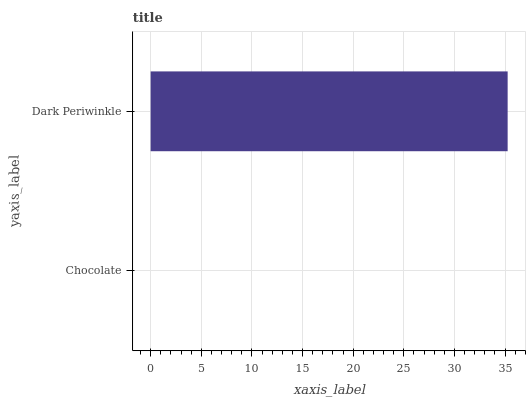Is Chocolate the minimum?
Answer yes or no. Yes. Is Dark Periwinkle the maximum?
Answer yes or no. Yes. Is Dark Periwinkle the minimum?
Answer yes or no. No. Is Dark Periwinkle greater than Chocolate?
Answer yes or no. Yes. Is Chocolate less than Dark Periwinkle?
Answer yes or no. Yes. Is Chocolate greater than Dark Periwinkle?
Answer yes or no. No. Is Dark Periwinkle less than Chocolate?
Answer yes or no. No. Is Dark Periwinkle the high median?
Answer yes or no. Yes. Is Chocolate the low median?
Answer yes or no. Yes. Is Chocolate the high median?
Answer yes or no. No. Is Dark Periwinkle the low median?
Answer yes or no. No. 